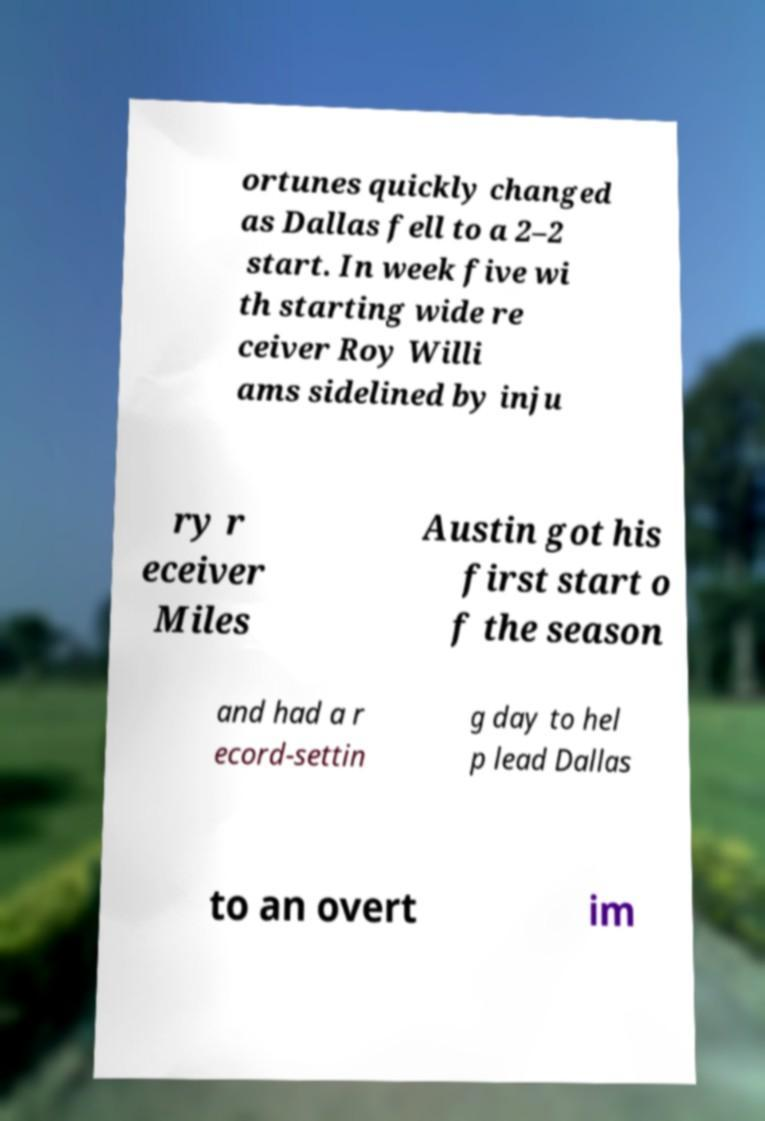Can you read and provide the text displayed in the image?This photo seems to have some interesting text. Can you extract and type it out for me? ortunes quickly changed as Dallas fell to a 2–2 start. In week five wi th starting wide re ceiver Roy Willi ams sidelined by inju ry r eceiver Miles Austin got his first start o f the season and had a r ecord-settin g day to hel p lead Dallas to an overt im 